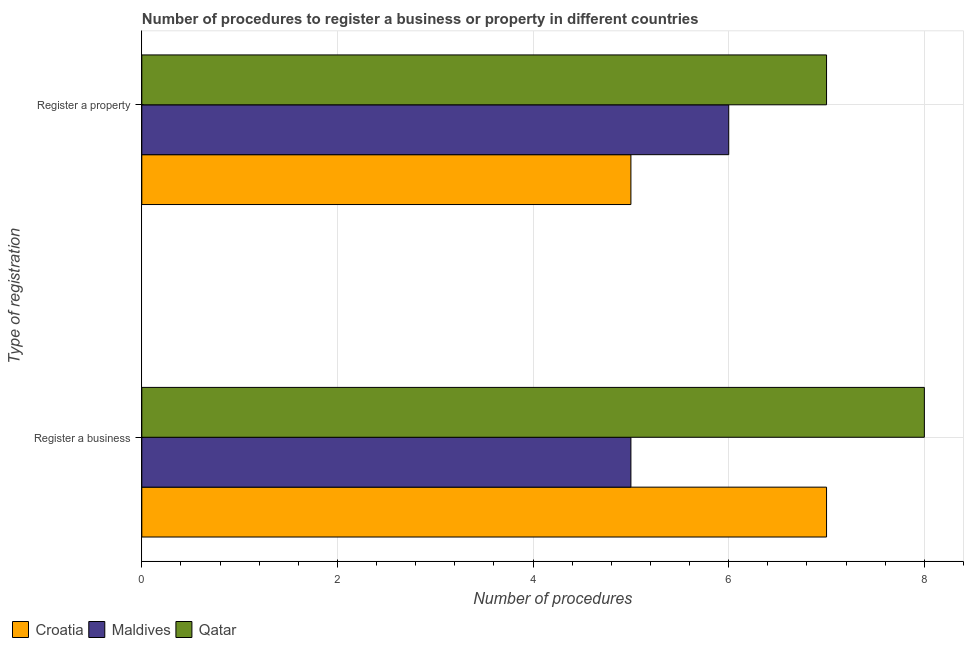Are the number of bars per tick equal to the number of legend labels?
Give a very brief answer. Yes. Are the number of bars on each tick of the Y-axis equal?
Provide a succinct answer. Yes. How many bars are there on the 1st tick from the top?
Offer a terse response. 3. How many bars are there on the 2nd tick from the bottom?
Offer a very short reply. 3. What is the label of the 2nd group of bars from the top?
Your answer should be compact. Register a business. What is the number of procedures to register a property in Croatia?
Your answer should be compact. 5. Across all countries, what is the maximum number of procedures to register a property?
Make the answer very short. 7. Across all countries, what is the minimum number of procedures to register a property?
Provide a succinct answer. 5. In which country was the number of procedures to register a business maximum?
Give a very brief answer. Qatar. In which country was the number of procedures to register a business minimum?
Ensure brevity in your answer.  Maldives. What is the total number of procedures to register a business in the graph?
Keep it short and to the point. 20. What is the difference between the number of procedures to register a business in Qatar and that in Maldives?
Your response must be concise. 3. What is the difference between the number of procedures to register a business in Croatia and the number of procedures to register a property in Maldives?
Offer a terse response. 1. What is the average number of procedures to register a business per country?
Your answer should be compact. 6.67. What is the difference between the number of procedures to register a property and number of procedures to register a business in Qatar?
Your answer should be very brief. -1. What is the ratio of the number of procedures to register a property in Croatia to that in Maldives?
Give a very brief answer. 0.83. Is the number of procedures to register a business in Maldives less than that in Croatia?
Offer a very short reply. Yes. In how many countries, is the number of procedures to register a business greater than the average number of procedures to register a business taken over all countries?
Offer a terse response. 2. What does the 1st bar from the top in Register a business represents?
Provide a succinct answer. Qatar. What does the 2nd bar from the bottom in Register a property represents?
Ensure brevity in your answer.  Maldives. Are all the bars in the graph horizontal?
Give a very brief answer. Yes. Does the graph contain grids?
Make the answer very short. Yes. How many legend labels are there?
Give a very brief answer. 3. What is the title of the graph?
Ensure brevity in your answer.  Number of procedures to register a business or property in different countries. What is the label or title of the X-axis?
Give a very brief answer. Number of procedures. What is the label or title of the Y-axis?
Make the answer very short. Type of registration. What is the Number of procedures in Croatia in Register a business?
Your answer should be very brief. 7. What is the Number of procedures in Qatar in Register a business?
Provide a short and direct response. 8. What is the Number of procedures in Maldives in Register a property?
Offer a very short reply. 6. Across all Type of registration, what is the maximum Number of procedures of Croatia?
Keep it short and to the point. 7. Across all Type of registration, what is the maximum Number of procedures in Maldives?
Your answer should be very brief. 6. Across all Type of registration, what is the maximum Number of procedures in Qatar?
Your answer should be very brief. 8. Across all Type of registration, what is the minimum Number of procedures in Qatar?
Give a very brief answer. 7. What is the total Number of procedures in Maldives in the graph?
Your response must be concise. 11. What is the total Number of procedures in Qatar in the graph?
Provide a succinct answer. 15. What is the difference between the Number of procedures in Croatia in Register a business and that in Register a property?
Provide a succinct answer. 2. What is the difference between the Number of procedures in Qatar in Register a business and that in Register a property?
Give a very brief answer. 1. What is the difference between the Number of procedures of Croatia in Register a business and the Number of procedures of Maldives in Register a property?
Offer a very short reply. 1. What is the difference between the Number of procedures in Croatia in Register a business and the Number of procedures in Qatar in Register a property?
Your answer should be very brief. 0. What is the difference between the Number of procedures of Maldives in Register a business and the Number of procedures of Qatar in Register a property?
Your answer should be compact. -2. What is the average Number of procedures of Croatia per Type of registration?
Offer a very short reply. 6. What is the average Number of procedures in Maldives per Type of registration?
Provide a short and direct response. 5.5. What is the difference between the Number of procedures of Croatia and Number of procedures of Maldives in Register a business?
Your answer should be compact. 2. What is the difference between the Number of procedures of Maldives and Number of procedures of Qatar in Register a business?
Offer a very short reply. -3. What is the difference between the Number of procedures in Croatia and Number of procedures in Maldives in Register a property?
Ensure brevity in your answer.  -1. What is the ratio of the Number of procedures in Croatia in Register a business to that in Register a property?
Provide a short and direct response. 1.4. What is the ratio of the Number of procedures in Qatar in Register a business to that in Register a property?
Provide a short and direct response. 1.14. What is the difference between the highest and the lowest Number of procedures in Croatia?
Your answer should be very brief. 2. What is the difference between the highest and the lowest Number of procedures of Qatar?
Provide a succinct answer. 1. 